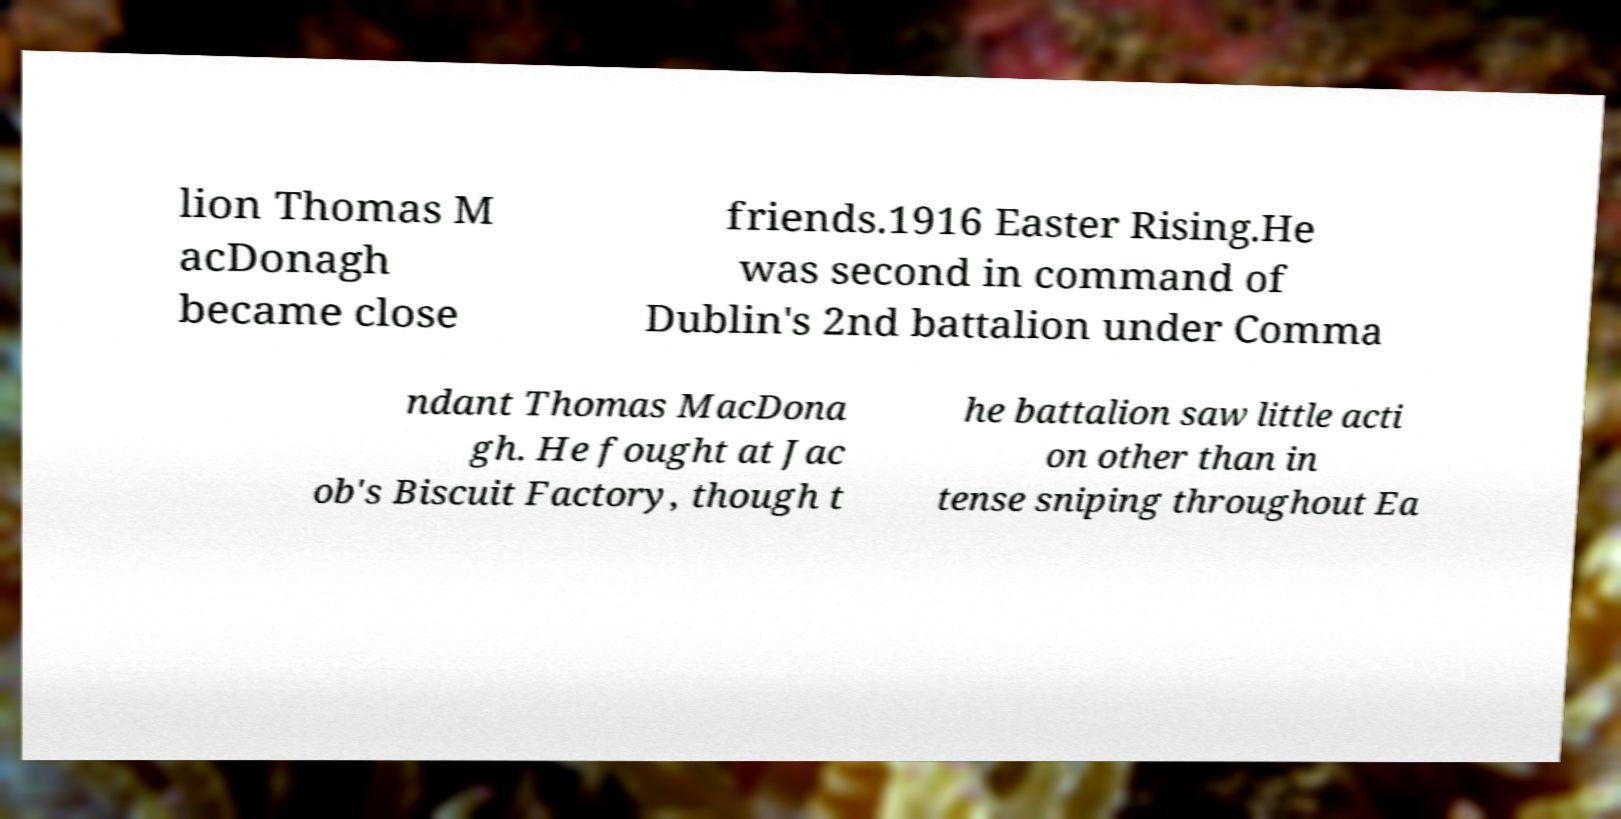There's text embedded in this image that I need extracted. Can you transcribe it verbatim? lion Thomas M acDonagh became close friends.1916 Easter Rising.He was second in command of Dublin's 2nd battalion under Comma ndant Thomas MacDona gh. He fought at Jac ob's Biscuit Factory, though t he battalion saw little acti on other than in tense sniping throughout Ea 